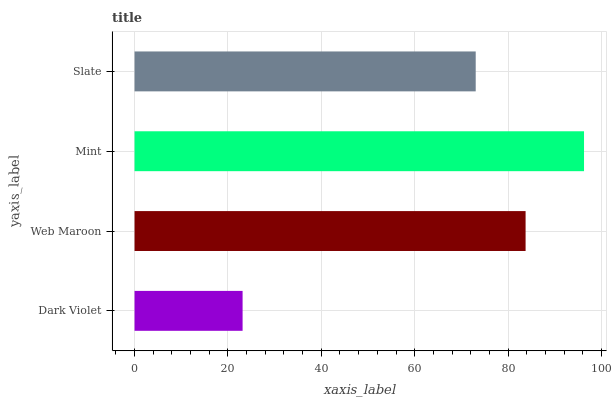Is Dark Violet the minimum?
Answer yes or no. Yes. Is Mint the maximum?
Answer yes or no. Yes. Is Web Maroon the minimum?
Answer yes or no. No. Is Web Maroon the maximum?
Answer yes or no. No. Is Web Maroon greater than Dark Violet?
Answer yes or no. Yes. Is Dark Violet less than Web Maroon?
Answer yes or no. Yes. Is Dark Violet greater than Web Maroon?
Answer yes or no. No. Is Web Maroon less than Dark Violet?
Answer yes or no. No. Is Web Maroon the high median?
Answer yes or no. Yes. Is Slate the low median?
Answer yes or no. Yes. Is Mint the high median?
Answer yes or no. No. Is Mint the low median?
Answer yes or no. No. 